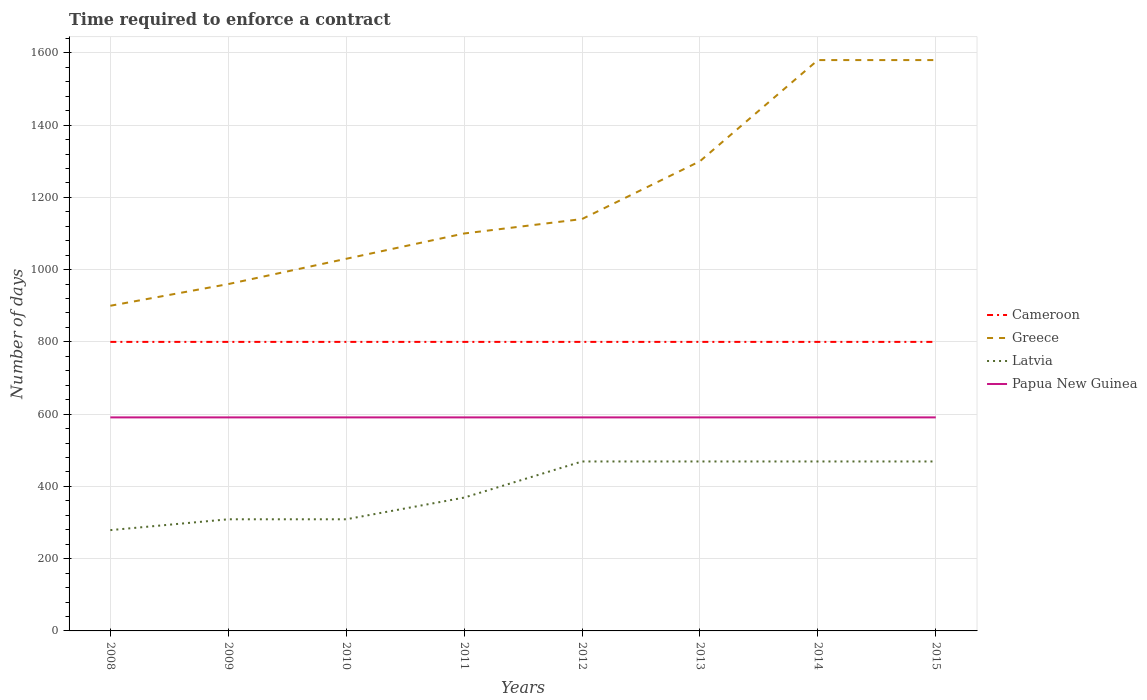Across all years, what is the maximum number of days required to enforce a contract in Greece?
Give a very brief answer. 900. In which year was the number of days required to enforce a contract in Cameroon maximum?
Your answer should be very brief. 2008. What is the difference between the highest and the second highest number of days required to enforce a contract in Cameroon?
Offer a terse response. 0. What is the difference between the highest and the lowest number of days required to enforce a contract in Papua New Guinea?
Provide a short and direct response. 0. How many lines are there?
Your answer should be very brief. 4. How many years are there in the graph?
Keep it short and to the point. 8. What is the difference between two consecutive major ticks on the Y-axis?
Provide a succinct answer. 200. Does the graph contain grids?
Your answer should be very brief. Yes. How are the legend labels stacked?
Offer a terse response. Vertical. What is the title of the graph?
Ensure brevity in your answer.  Time required to enforce a contract. Does "Philippines" appear as one of the legend labels in the graph?
Provide a short and direct response. No. What is the label or title of the X-axis?
Ensure brevity in your answer.  Years. What is the label or title of the Y-axis?
Ensure brevity in your answer.  Number of days. What is the Number of days in Cameroon in 2008?
Provide a short and direct response. 800. What is the Number of days in Greece in 2008?
Keep it short and to the point. 900. What is the Number of days in Latvia in 2008?
Your answer should be very brief. 279. What is the Number of days of Papua New Guinea in 2008?
Your response must be concise. 591. What is the Number of days of Cameroon in 2009?
Your answer should be very brief. 800. What is the Number of days of Greece in 2009?
Keep it short and to the point. 960. What is the Number of days in Latvia in 2009?
Your answer should be very brief. 309. What is the Number of days of Papua New Guinea in 2009?
Offer a terse response. 591. What is the Number of days of Cameroon in 2010?
Your answer should be compact. 800. What is the Number of days in Greece in 2010?
Your answer should be compact. 1030. What is the Number of days of Latvia in 2010?
Ensure brevity in your answer.  309. What is the Number of days of Papua New Guinea in 2010?
Your answer should be compact. 591. What is the Number of days in Cameroon in 2011?
Provide a short and direct response. 800. What is the Number of days of Greece in 2011?
Make the answer very short. 1100. What is the Number of days of Latvia in 2011?
Make the answer very short. 369. What is the Number of days in Papua New Guinea in 2011?
Provide a short and direct response. 591. What is the Number of days of Cameroon in 2012?
Offer a very short reply. 800. What is the Number of days in Greece in 2012?
Provide a succinct answer. 1140. What is the Number of days of Latvia in 2012?
Provide a succinct answer. 469. What is the Number of days of Papua New Guinea in 2012?
Keep it short and to the point. 591. What is the Number of days in Cameroon in 2013?
Ensure brevity in your answer.  800. What is the Number of days in Greece in 2013?
Your answer should be compact. 1300. What is the Number of days in Latvia in 2013?
Ensure brevity in your answer.  469. What is the Number of days in Papua New Guinea in 2013?
Provide a succinct answer. 591. What is the Number of days of Cameroon in 2014?
Offer a very short reply. 800. What is the Number of days in Greece in 2014?
Your response must be concise. 1580. What is the Number of days in Latvia in 2014?
Provide a succinct answer. 469. What is the Number of days of Papua New Guinea in 2014?
Provide a short and direct response. 591. What is the Number of days of Cameroon in 2015?
Give a very brief answer. 800. What is the Number of days in Greece in 2015?
Your answer should be very brief. 1580. What is the Number of days of Latvia in 2015?
Keep it short and to the point. 469. What is the Number of days of Papua New Guinea in 2015?
Your answer should be very brief. 591. Across all years, what is the maximum Number of days of Cameroon?
Provide a short and direct response. 800. Across all years, what is the maximum Number of days of Greece?
Offer a very short reply. 1580. Across all years, what is the maximum Number of days of Latvia?
Ensure brevity in your answer.  469. Across all years, what is the maximum Number of days in Papua New Guinea?
Make the answer very short. 591. Across all years, what is the minimum Number of days of Cameroon?
Provide a short and direct response. 800. Across all years, what is the minimum Number of days in Greece?
Offer a very short reply. 900. Across all years, what is the minimum Number of days in Latvia?
Provide a succinct answer. 279. Across all years, what is the minimum Number of days in Papua New Guinea?
Provide a succinct answer. 591. What is the total Number of days in Cameroon in the graph?
Your answer should be very brief. 6400. What is the total Number of days of Greece in the graph?
Provide a short and direct response. 9590. What is the total Number of days of Latvia in the graph?
Your answer should be very brief. 3142. What is the total Number of days of Papua New Guinea in the graph?
Offer a terse response. 4728. What is the difference between the Number of days of Greece in 2008 and that in 2009?
Your answer should be compact. -60. What is the difference between the Number of days in Latvia in 2008 and that in 2009?
Your answer should be very brief. -30. What is the difference between the Number of days of Papua New Guinea in 2008 and that in 2009?
Provide a short and direct response. 0. What is the difference between the Number of days of Cameroon in 2008 and that in 2010?
Make the answer very short. 0. What is the difference between the Number of days in Greece in 2008 and that in 2010?
Ensure brevity in your answer.  -130. What is the difference between the Number of days in Latvia in 2008 and that in 2010?
Give a very brief answer. -30. What is the difference between the Number of days in Cameroon in 2008 and that in 2011?
Provide a succinct answer. 0. What is the difference between the Number of days in Greece in 2008 and that in 2011?
Give a very brief answer. -200. What is the difference between the Number of days in Latvia in 2008 and that in 2011?
Offer a very short reply. -90. What is the difference between the Number of days in Cameroon in 2008 and that in 2012?
Offer a terse response. 0. What is the difference between the Number of days in Greece in 2008 and that in 2012?
Provide a succinct answer. -240. What is the difference between the Number of days of Latvia in 2008 and that in 2012?
Provide a succinct answer. -190. What is the difference between the Number of days in Papua New Guinea in 2008 and that in 2012?
Ensure brevity in your answer.  0. What is the difference between the Number of days in Cameroon in 2008 and that in 2013?
Your answer should be compact. 0. What is the difference between the Number of days in Greece in 2008 and that in 2013?
Provide a succinct answer. -400. What is the difference between the Number of days of Latvia in 2008 and that in 2013?
Your answer should be very brief. -190. What is the difference between the Number of days in Cameroon in 2008 and that in 2014?
Make the answer very short. 0. What is the difference between the Number of days of Greece in 2008 and that in 2014?
Make the answer very short. -680. What is the difference between the Number of days of Latvia in 2008 and that in 2014?
Offer a very short reply. -190. What is the difference between the Number of days in Greece in 2008 and that in 2015?
Ensure brevity in your answer.  -680. What is the difference between the Number of days of Latvia in 2008 and that in 2015?
Your answer should be very brief. -190. What is the difference between the Number of days in Cameroon in 2009 and that in 2010?
Offer a terse response. 0. What is the difference between the Number of days in Greece in 2009 and that in 2010?
Keep it short and to the point. -70. What is the difference between the Number of days of Papua New Guinea in 2009 and that in 2010?
Provide a short and direct response. 0. What is the difference between the Number of days in Cameroon in 2009 and that in 2011?
Give a very brief answer. 0. What is the difference between the Number of days in Greece in 2009 and that in 2011?
Keep it short and to the point. -140. What is the difference between the Number of days in Latvia in 2009 and that in 2011?
Your answer should be compact. -60. What is the difference between the Number of days in Cameroon in 2009 and that in 2012?
Your answer should be very brief. 0. What is the difference between the Number of days of Greece in 2009 and that in 2012?
Make the answer very short. -180. What is the difference between the Number of days of Latvia in 2009 and that in 2012?
Make the answer very short. -160. What is the difference between the Number of days in Cameroon in 2009 and that in 2013?
Offer a terse response. 0. What is the difference between the Number of days in Greece in 2009 and that in 2013?
Your response must be concise. -340. What is the difference between the Number of days in Latvia in 2009 and that in 2013?
Offer a very short reply. -160. What is the difference between the Number of days in Greece in 2009 and that in 2014?
Offer a very short reply. -620. What is the difference between the Number of days of Latvia in 2009 and that in 2014?
Your response must be concise. -160. What is the difference between the Number of days of Papua New Guinea in 2009 and that in 2014?
Provide a short and direct response. 0. What is the difference between the Number of days in Greece in 2009 and that in 2015?
Offer a terse response. -620. What is the difference between the Number of days in Latvia in 2009 and that in 2015?
Provide a short and direct response. -160. What is the difference between the Number of days in Greece in 2010 and that in 2011?
Offer a terse response. -70. What is the difference between the Number of days in Latvia in 2010 and that in 2011?
Offer a very short reply. -60. What is the difference between the Number of days in Greece in 2010 and that in 2012?
Give a very brief answer. -110. What is the difference between the Number of days of Latvia in 2010 and that in 2012?
Your answer should be very brief. -160. What is the difference between the Number of days of Greece in 2010 and that in 2013?
Ensure brevity in your answer.  -270. What is the difference between the Number of days in Latvia in 2010 and that in 2013?
Your response must be concise. -160. What is the difference between the Number of days of Greece in 2010 and that in 2014?
Make the answer very short. -550. What is the difference between the Number of days in Latvia in 2010 and that in 2014?
Your answer should be very brief. -160. What is the difference between the Number of days of Papua New Guinea in 2010 and that in 2014?
Give a very brief answer. 0. What is the difference between the Number of days in Cameroon in 2010 and that in 2015?
Give a very brief answer. 0. What is the difference between the Number of days of Greece in 2010 and that in 2015?
Your response must be concise. -550. What is the difference between the Number of days in Latvia in 2010 and that in 2015?
Offer a terse response. -160. What is the difference between the Number of days of Cameroon in 2011 and that in 2012?
Your answer should be compact. 0. What is the difference between the Number of days of Latvia in 2011 and that in 2012?
Offer a very short reply. -100. What is the difference between the Number of days of Cameroon in 2011 and that in 2013?
Your answer should be very brief. 0. What is the difference between the Number of days of Greece in 2011 and that in 2013?
Keep it short and to the point. -200. What is the difference between the Number of days of Latvia in 2011 and that in 2013?
Provide a short and direct response. -100. What is the difference between the Number of days in Papua New Guinea in 2011 and that in 2013?
Give a very brief answer. 0. What is the difference between the Number of days of Greece in 2011 and that in 2014?
Offer a terse response. -480. What is the difference between the Number of days of Latvia in 2011 and that in 2014?
Offer a very short reply. -100. What is the difference between the Number of days of Papua New Guinea in 2011 and that in 2014?
Make the answer very short. 0. What is the difference between the Number of days in Cameroon in 2011 and that in 2015?
Provide a short and direct response. 0. What is the difference between the Number of days of Greece in 2011 and that in 2015?
Offer a very short reply. -480. What is the difference between the Number of days in Latvia in 2011 and that in 2015?
Provide a succinct answer. -100. What is the difference between the Number of days of Papua New Guinea in 2011 and that in 2015?
Give a very brief answer. 0. What is the difference between the Number of days in Cameroon in 2012 and that in 2013?
Provide a succinct answer. 0. What is the difference between the Number of days of Greece in 2012 and that in 2013?
Provide a short and direct response. -160. What is the difference between the Number of days of Latvia in 2012 and that in 2013?
Ensure brevity in your answer.  0. What is the difference between the Number of days in Papua New Guinea in 2012 and that in 2013?
Offer a terse response. 0. What is the difference between the Number of days in Cameroon in 2012 and that in 2014?
Give a very brief answer. 0. What is the difference between the Number of days in Greece in 2012 and that in 2014?
Offer a terse response. -440. What is the difference between the Number of days of Latvia in 2012 and that in 2014?
Your answer should be very brief. 0. What is the difference between the Number of days in Greece in 2012 and that in 2015?
Provide a short and direct response. -440. What is the difference between the Number of days of Latvia in 2012 and that in 2015?
Your response must be concise. 0. What is the difference between the Number of days in Papua New Guinea in 2012 and that in 2015?
Offer a very short reply. 0. What is the difference between the Number of days of Cameroon in 2013 and that in 2014?
Ensure brevity in your answer.  0. What is the difference between the Number of days of Greece in 2013 and that in 2014?
Make the answer very short. -280. What is the difference between the Number of days of Cameroon in 2013 and that in 2015?
Ensure brevity in your answer.  0. What is the difference between the Number of days of Greece in 2013 and that in 2015?
Keep it short and to the point. -280. What is the difference between the Number of days of Latvia in 2013 and that in 2015?
Your answer should be very brief. 0. What is the difference between the Number of days of Papua New Guinea in 2013 and that in 2015?
Offer a terse response. 0. What is the difference between the Number of days in Cameroon in 2014 and that in 2015?
Offer a very short reply. 0. What is the difference between the Number of days in Greece in 2014 and that in 2015?
Provide a short and direct response. 0. What is the difference between the Number of days in Latvia in 2014 and that in 2015?
Your response must be concise. 0. What is the difference between the Number of days of Papua New Guinea in 2014 and that in 2015?
Ensure brevity in your answer.  0. What is the difference between the Number of days of Cameroon in 2008 and the Number of days of Greece in 2009?
Offer a terse response. -160. What is the difference between the Number of days of Cameroon in 2008 and the Number of days of Latvia in 2009?
Ensure brevity in your answer.  491. What is the difference between the Number of days of Cameroon in 2008 and the Number of days of Papua New Guinea in 2009?
Make the answer very short. 209. What is the difference between the Number of days of Greece in 2008 and the Number of days of Latvia in 2009?
Provide a short and direct response. 591. What is the difference between the Number of days in Greece in 2008 and the Number of days in Papua New Guinea in 2009?
Ensure brevity in your answer.  309. What is the difference between the Number of days of Latvia in 2008 and the Number of days of Papua New Guinea in 2009?
Offer a very short reply. -312. What is the difference between the Number of days in Cameroon in 2008 and the Number of days in Greece in 2010?
Provide a short and direct response. -230. What is the difference between the Number of days of Cameroon in 2008 and the Number of days of Latvia in 2010?
Make the answer very short. 491. What is the difference between the Number of days of Cameroon in 2008 and the Number of days of Papua New Guinea in 2010?
Your answer should be compact. 209. What is the difference between the Number of days in Greece in 2008 and the Number of days in Latvia in 2010?
Make the answer very short. 591. What is the difference between the Number of days of Greece in 2008 and the Number of days of Papua New Guinea in 2010?
Give a very brief answer. 309. What is the difference between the Number of days in Latvia in 2008 and the Number of days in Papua New Guinea in 2010?
Provide a short and direct response. -312. What is the difference between the Number of days in Cameroon in 2008 and the Number of days in Greece in 2011?
Your response must be concise. -300. What is the difference between the Number of days of Cameroon in 2008 and the Number of days of Latvia in 2011?
Your answer should be compact. 431. What is the difference between the Number of days of Cameroon in 2008 and the Number of days of Papua New Guinea in 2011?
Offer a terse response. 209. What is the difference between the Number of days of Greece in 2008 and the Number of days of Latvia in 2011?
Provide a succinct answer. 531. What is the difference between the Number of days of Greece in 2008 and the Number of days of Papua New Guinea in 2011?
Make the answer very short. 309. What is the difference between the Number of days in Latvia in 2008 and the Number of days in Papua New Guinea in 2011?
Your response must be concise. -312. What is the difference between the Number of days in Cameroon in 2008 and the Number of days in Greece in 2012?
Your answer should be very brief. -340. What is the difference between the Number of days of Cameroon in 2008 and the Number of days of Latvia in 2012?
Make the answer very short. 331. What is the difference between the Number of days in Cameroon in 2008 and the Number of days in Papua New Guinea in 2012?
Offer a very short reply. 209. What is the difference between the Number of days in Greece in 2008 and the Number of days in Latvia in 2012?
Offer a very short reply. 431. What is the difference between the Number of days in Greece in 2008 and the Number of days in Papua New Guinea in 2012?
Make the answer very short. 309. What is the difference between the Number of days of Latvia in 2008 and the Number of days of Papua New Guinea in 2012?
Your answer should be compact. -312. What is the difference between the Number of days of Cameroon in 2008 and the Number of days of Greece in 2013?
Keep it short and to the point. -500. What is the difference between the Number of days of Cameroon in 2008 and the Number of days of Latvia in 2013?
Your answer should be compact. 331. What is the difference between the Number of days in Cameroon in 2008 and the Number of days in Papua New Guinea in 2013?
Your answer should be very brief. 209. What is the difference between the Number of days in Greece in 2008 and the Number of days in Latvia in 2013?
Keep it short and to the point. 431. What is the difference between the Number of days in Greece in 2008 and the Number of days in Papua New Guinea in 2013?
Your answer should be compact. 309. What is the difference between the Number of days in Latvia in 2008 and the Number of days in Papua New Guinea in 2013?
Your response must be concise. -312. What is the difference between the Number of days of Cameroon in 2008 and the Number of days of Greece in 2014?
Make the answer very short. -780. What is the difference between the Number of days of Cameroon in 2008 and the Number of days of Latvia in 2014?
Provide a short and direct response. 331. What is the difference between the Number of days of Cameroon in 2008 and the Number of days of Papua New Guinea in 2014?
Your answer should be compact. 209. What is the difference between the Number of days in Greece in 2008 and the Number of days in Latvia in 2014?
Offer a terse response. 431. What is the difference between the Number of days of Greece in 2008 and the Number of days of Papua New Guinea in 2014?
Make the answer very short. 309. What is the difference between the Number of days of Latvia in 2008 and the Number of days of Papua New Guinea in 2014?
Ensure brevity in your answer.  -312. What is the difference between the Number of days of Cameroon in 2008 and the Number of days of Greece in 2015?
Your answer should be very brief. -780. What is the difference between the Number of days in Cameroon in 2008 and the Number of days in Latvia in 2015?
Offer a terse response. 331. What is the difference between the Number of days of Cameroon in 2008 and the Number of days of Papua New Guinea in 2015?
Offer a terse response. 209. What is the difference between the Number of days of Greece in 2008 and the Number of days of Latvia in 2015?
Provide a short and direct response. 431. What is the difference between the Number of days of Greece in 2008 and the Number of days of Papua New Guinea in 2015?
Give a very brief answer. 309. What is the difference between the Number of days of Latvia in 2008 and the Number of days of Papua New Guinea in 2015?
Give a very brief answer. -312. What is the difference between the Number of days of Cameroon in 2009 and the Number of days of Greece in 2010?
Provide a short and direct response. -230. What is the difference between the Number of days in Cameroon in 2009 and the Number of days in Latvia in 2010?
Offer a terse response. 491. What is the difference between the Number of days in Cameroon in 2009 and the Number of days in Papua New Guinea in 2010?
Your answer should be compact. 209. What is the difference between the Number of days in Greece in 2009 and the Number of days in Latvia in 2010?
Provide a short and direct response. 651. What is the difference between the Number of days in Greece in 2009 and the Number of days in Papua New Guinea in 2010?
Your answer should be very brief. 369. What is the difference between the Number of days of Latvia in 2009 and the Number of days of Papua New Guinea in 2010?
Make the answer very short. -282. What is the difference between the Number of days in Cameroon in 2009 and the Number of days in Greece in 2011?
Your answer should be very brief. -300. What is the difference between the Number of days in Cameroon in 2009 and the Number of days in Latvia in 2011?
Offer a very short reply. 431. What is the difference between the Number of days in Cameroon in 2009 and the Number of days in Papua New Guinea in 2011?
Keep it short and to the point. 209. What is the difference between the Number of days of Greece in 2009 and the Number of days of Latvia in 2011?
Make the answer very short. 591. What is the difference between the Number of days of Greece in 2009 and the Number of days of Papua New Guinea in 2011?
Offer a very short reply. 369. What is the difference between the Number of days in Latvia in 2009 and the Number of days in Papua New Guinea in 2011?
Offer a terse response. -282. What is the difference between the Number of days in Cameroon in 2009 and the Number of days in Greece in 2012?
Give a very brief answer. -340. What is the difference between the Number of days in Cameroon in 2009 and the Number of days in Latvia in 2012?
Your response must be concise. 331. What is the difference between the Number of days of Cameroon in 2009 and the Number of days of Papua New Guinea in 2012?
Provide a short and direct response. 209. What is the difference between the Number of days of Greece in 2009 and the Number of days of Latvia in 2012?
Keep it short and to the point. 491. What is the difference between the Number of days in Greece in 2009 and the Number of days in Papua New Guinea in 2012?
Offer a terse response. 369. What is the difference between the Number of days of Latvia in 2009 and the Number of days of Papua New Guinea in 2012?
Offer a terse response. -282. What is the difference between the Number of days of Cameroon in 2009 and the Number of days of Greece in 2013?
Give a very brief answer. -500. What is the difference between the Number of days of Cameroon in 2009 and the Number of days of Latvia in 2013?
Provide a succinct answer. 331. What is the difference between the Number of days in Cameroon in 2009 and the Number of days in Papua New Guinea in 2013?
Keep it short and to the point. 209. What is the difference between the Number of days of Greece in 2009 and the Number of days of Latvia in 2013?
Keep it short and to the point. 491. What is the difference between the Number of days in Greece in 2009 and the Number of days in Papua New Guinea in 2013?
Provide a short and direct response. 369. What is the difference between the Number of days in Latvia in 2009 and the Number of days in Papua New Guinea in 2013?
Your response must be concise. -282. What is the difference between the Number of days in Cameroon in 2009 and the Number of days in Greece in 2014?
Ensure brevity in your answer.  -780. What is the difference between the Number of days of Cameroon in 2009 and the Number of days of Latvia in 2014?
Offer a terse response. 331. What is the difference between the Number of days in Cameroon in 2009 and the Number of days in Papua New Guinea in 2014?
Offer a terse response. 209. What is the difference between the Number of days in Greece in 2009 and the Number of days in Latvia in 2014?
Give a very brief answer. 491. What is the difference between the Number of days of Greece in 2009 and the Number of days of Papua New Guinea in 2014?
Your answer should be compact. 369. What is the difference between the Number of days of Latvia in 2009 and the Number of days of Papua New Guinea in 2014?
Your answer should be compact. -282. What is the difference between the Number of days in Cameroon in 2009 and the Number of days in Greece in 2015?
Your answer should be very brief. -780. What is the difference between the Number of days in Cameroon in 2009 and the Number of days in Latvia in 2015?
Your response must be concise. 331. What is the difference between the Number of days of Cameroon in 2009 and the Number of days of Papua New Guinea in 2015?
Offer a very short reply. 209. What is the difference between the Number of days in Greece in 2009 and the Number of days in Latvia in 2015?
Your response must be concise. 491. What is the difference between the Number of days of Greece in 2009 and the Number of days of Papua New Guinea in 2015?
Provide a succinct answer. 369. What is the difference between the Number of days of Latvia in 2009 and the Number of days of Papua New Guinea in 2015?
Your answer should be very brief. -282. What is the difference between the Number of days in Cameroon in 2010 and the Number of days in Greece in 2011?
Make the answer very short. -300. What is the difference between the Number of days in Cameroon in 2010 and the Number of days in Latvia in 2011?
Offer a very short reply. 431. What is the difference between the Number of days in Cameroon in 2010 and the Number of days in Papua New Guinea in 2011?
Offer a very short reply. 209. What is the difference between the Number of days of Greece in 2010 and the Number of days of Latvia in 2011?
Ensure brevity in your answer.  661. What is the difference between the Number of days in Greece in 2010 and the Number of days in Papua New Guinea in 2011?
Offer a very short reply. 439. What is the difference between the Number of days of Latvia in 2010 and the Number of days of Papua New Guinea in 2011?
Your response must be concise. -282. What is the difference between the Number of days of Cameroon in 2010 and the Number of days of Greece in 2012?
Your response must be concise. -340. What is the difference between the Number of days in Cameroon in 2010 and the Number of days in Latvia in 2012?
Your answer should be very brief. 331. What is the difference between the Number of days of Cameroon in 2010 and the Number of days of Papua New Guinea in 2012?
Make the answer very short. 209. What is the difference between the Number of days in Greece in 2010 and the Number of days in Latvia in 2012?
Your answer should be compact. 561. What is the difference between the Number of days of Greece in 2010 and the Number of days of Papua New Guinea in 2012?
Your answer should be compact. 439. What is the difference between the Number of days of Latvia in 2010 and the Number of days of Papua New Guinea in 2012?
Give a very brief answer. -282. What is the difference between the Number of days in Cameroon in 2010 and the Number of days in Greece in 2013?
Your answer should be compact. -500. What is the difference between the Number of days in Cameroon in 2010 and the Number of days in Latvia in 2013?
Give a very brief answer. 331. What is the difference between the Number of days of Cameroon in 2010 and the Number of days of Papua New Guinea in 2013?
Offer a terse response. 209. What is the difference between the Number of days in Greece in 2010 and the Number of days in Latvia in 2013?
Your answer should be very brief. 561. What is the difference between the Number of days of Greece in 2010 and the Number of days of Papua New Guinea in 2013?
Offer a very short reply. 439. What is the difference between the Number of days in Latvia in 2010 and the Number of days in Papua New Guinea in 2013?
Your answer should be very brief. -282. What is the difference between the Number of days of Cameroon in 2010 and the Number of days of Greece in 2014?
Your response must be concise. -780. What is the difference between the Number of days in Cameroon in 2010 and the Number of days in Latvia in 2014?
Your answer should be very brief. 331. What is the difference between the Number of days of Cameroon in 2010 and the Number of days of Papua New Guinea in 2014?
Ensure brevity in your answer.  209. What is the difference between the Number of days in Greece in 2010 and the Number of days in Latvia in 2014?
Provide a short and direct response. 561. What is the difference between the Number of days of Greece in 2010 and the Number of days of Papua New Guinea in 2014?
Give a very brief answer. 439. What is the difference between the Number of days of Latvia in 2010 and the Number of days of Papua New Guinea in 2014?
Make the answer very short. -282. What is the difference between the Number of days of Cameroon in 2010 and the Number of days of Greece in 2015?
Provide a succinct answer. -780. What is the difference between the Number of days of Cameroon in 2010 and the Number of days of Latvia in 2015?
Provide a succinct answer. 331. What is the difference between the Number of days of Cameroon in 2010 and the Number of days of Papua New Guinea in 2015?
Ensure brevity in your answer.  209. What is the difference between the Number of days in Greece in 2010 and the Number of days in Latvia in 2015?
Your answer should be very brief. 561. What is the difference between the Number of days of Greece in 2010 and the Number of days of Papua New Guinea in 2015?
Provide a succinct answer. 439. What is the difference between the Number of days in Latvia in 2010 and the Number of days in Papua New Guinea in 2015?
Give a very brief answer. -282. What is the difference between the Number of days in Cameroon in 2011 and the Number of days in Greece in 2012?
Offer a very short reply. -340. What is the difference between the Number of days in Cameroon in 2011 and the Number of days in Latvia in 2012?
Offer a very short reply. 331. What is the difference between the Number of days in Cameroon in 2011 and the Number of days in Papua New Guinea in 2012?
Keep it short and to the point. 209. What is the difference between the Number of days of Greece in 2011 and the Number of days of Latvia in 2012?
Offer a terse response. 631. What is the difference between the Number of days in Greece in 2011 and the Number of days in Papua New Guinea in 2012?
Offer a terse response. 509. What is the difference between the Number of days in Latvia in 2011 and the Number of days in Papua New Guinea in 2012?
Your answer should be compact. -222. What is the difference between the Number of days in Cameroon in 2011 and the Number of days in Greece in 2013?
Give a very brief answer. -500. What is the difference between the Number of days of Cameroon in 2011 and the Number of days of Latvia in 2013?
Ensure brevity in your answer.  331. What is the difference between the Number of days in Cameroon in 2011 and the Number of days in Papua New Guinea in 2013?
Give a very brief answer. 209. What is the difference between the Number of days of Greece in 2011 and the Number of days of Latvia in 2013?
Your response must be concise. 631. What is the difference between the Number of days in Greece in 2011 and the Number of days in Papua New Guinea in 2013?
Your answer should be compact. 509. What is the difference between the Number of days of Latvia in 2011 and the Number of days of Papua New Guinea in 2013?
Provide a succinct answer. -222. What is the difference between the Number of days of Cameroon in 2011 and the Number of days of Greece in 2014?
Offer a terse response. -780. What is the difference between the Number of days in Cameroon in 2011 and the Number of days in Latvia in 2014?
Provide a succinct answer. 331. What is the difference between the Number of days of Cameroon in 2011 and the Number of days of Papua New Guinea in 2014?
Give a very brief answer. 209. What is the difference between the Number of days in Greece in 2011 and the Number of days in Latvia in 2014?
Give a very brief answer. 631. What is the difference between the Number of days in Greece in 2011 and the Number of days in Papua New Guinea in 2014?
Give a very brief answer. 509. What is the difference between the Number of days of Latvia in 2011 and the Number of days of Papua New Guinea in 2014?
Provide a succinct answer. -222. What is the difference between the Number of days in Cameroon in 2011 and the Number of days in Greece in 2015?
Keep it short and to the point. -780. What is the difference between the Number of days of Cameroon in 2011 and the Number of days of Latvia in 2015?
Offer a terse response. 331. What is the difference between the Number of days of Cameroon in 2011 and the Number of days of Papua New Guinea in 2015?
Your response must be concise. 209. What is the difference between the Number of days of Greece in 2011 and the Number of days of Latvia in 2015?
Offer a terse response. 631. What is the difference between the Number of days in Greece in 2011 and the Number of days in Papua New Guinea in 2015?
Provide a succinct answer. 509. What is the difference between the Number of days in Latvia in 2011 and the Number of days in Papua New Guinea in 2015?
Provide a short and direct response. -222. What is the difference between the Number of days of Cameroon in 2012 and the Number of days of Greece in 2013?
Offer a very short reply. -500. What is the difference between the Number of days in Cameroon in 2012 and the Number of days in Latvia in 2013?
Provide a succinct answer. 331. What is the difference between the Number of days of Cameroon in 2012 and the Number of days of Papua New Guinea in 2013?
Give a very brief answer. 209. What is the difference between the Number of days in Greece in 2012 and the Number of days in Latvia in 2013?
Offer a terse response. 671. What is the difference between the Number of days in Greece in 2012 and the Number of days in Papua New Guinea in 2013?
Keep it short and to the point. 549. What is the difference between the Number of days in Latvia in 2012 and the Number of days in Papua New Guinea in 2013?
Give a very brief answer. -122. What is the difference between the Number of days of Cameroon in 2012 and the Number of days of Greece in 2014?
Your answer should be compact. -780. What is the difference between the Number of days in Cameroon in 2012 and the Number of days in Latvia in 2014?
Provide a short and direct response. 331. What is the difference between the Number of days of Cameroon in 2012 and the Number of days of Papua New Guinea in 2014?
Keep it short and to the point. 209. What is the difference between the Number of days of Greece in 2012 and the Number of days of Latvia in 2014?
Your answer should be compact. 671. What is the difference between the Number of days in Greece in 2012 and the Number of days in Papua New Guinea in 2014?
Offer a very short reply. 549. What is the difference between the Number of days in Latvia in 2012 and the Number of days in Papua New Guinea in 2014?
Provide a short and direct response. -122. What is the difference between the Number of days in Cameroon in 2012 and the Number of days in Greece in 2015?
Provide a succinct answer. -780. What is the difference between the Number of days of Cameroon in 2012 and the Number of days of Latvia in 2015?
Your answer should be very brief. 331. What is the difference between the Number of days of Cameroon in 2012 and the Number of days of Papua New Guinea in 2015?
Your answer should be very brief. 209. What is the difference between the Number of days of Greece in 2012 and the Number of days of Latvia in 2015?
Your answer should be very brief. 671. What is the difference between the Number of days in Greece in 2012 and the Number of days in Papua New Guinea in 2015?
Offer a very short reply. 549. What is the difference between the Number of days of Latvia in 2012 and the Number of days of Papua New Guinea in 2015?
Make the answer very short. -122. What is the difference between the Number of days in Cameroon in 2013 and the Number of days in Greece in 2014?
Your answer should be very brief. -780. What is the difference between the Number of days of Cameroon in 2013 and the Number of days of Latvia in 2014?
Your answer should be very brief. 331. What is the difference between the Number of days in Cameroon in 2013 and the Number of days in Papua New Guinea in 2014?
Your answer should be very brief. 209. What is the difference between the Number of days of Greece in 2013 and the Number of days of Latvia in 2014?
Ensure brevity in your answer.  831. What is the difference between the Number of days in Greece in 2013 and the Number of days in Papua New Guinea in 2014?
Your answer should be very brief. 709. What is the difference between the Number of days in Latvia in 2013 and the Number of days in Papua New Guinea in 2014?
Make the answer very short. -122. What is the difference between the Number of days in Cameroon in 2013 and the Number of days in Greece in 2015?
Your answer should be compact. -780. What is the difference between the Number of days in Cameroon in 2013 and the Number of days in Latvia in 2015?
Make the answer very short. 331. What is the difference between the Number of days of Cameroon in 2013 and the Number of days of Papua New Guinea in 2015?
Ensure brevity in your answer.  209. What is the difference between the Number of days of Greece in 2013 and the Number of days of Latvia in 2015?
Your answer should be very brief. 831. What is the difference between the Number of days of Greece in 2013 and the Number of days of Papua New Guinea in 2015?
Ensure brevity in your answer.  709. What is the difference between the Number of days in Latvia in 2013 and the Number of days in Papua New Guinea in 2015?
Give a very brief answer. -122. What is the difference between the Number of days in Cameroon in 2014 and the Number of days in Greece in 2015?
Keep it short and to the point. -780. What is the difference between the Number of days in Cameroon in 2014 and the Number of days in Latvia in 2015?
Give a very brief answer. 331. What is the difference between the Number of days in Cameroon in 2014 and the Number of days in Papua New Guinea in 2015?
Make the answer very short. 209. What is the difference between the Number of days in Greece in 2014 and the Number of days in Latvia in 2015?
Make the answer very short. 1111. What is the difference between the Number of days of Greece in 2014 and the Number of days of Papua New Guinea in 2015?
Offer a terse response. 989. What is the difference between the Number of days in Latvia in 2014 and the Number of days in Papua New Guinea in 2015?
Offer a very short reply. -122. What is the average Number of days in Cameroon per year?
Ensure brevity in your answer.  800. What is the average Number of days of Greece per year?
Ensure brevity in your answer.  1198.75. What is the average Number of days in Latvia per year?
Offer a very short reply. 392.75. What is the average Number of days of Papua New Guinea per year?
Offer a very short reply. 591. In the year 2008, what is the difference between the Number of days of Cameroon and Number of days of Greece?
Give a very brief answer. -100. In the year 2008, what is the difference between the Number of days of Cameroon and Number of days of Latvia?
Provide a succinct answer. 521. In the year 2008, what is the difference between the Number of days of Cameroon and Number of days of Papua New Guinea?
Provide a short and direct response. 209. In the year 2008, what is the difference between the Number of days of Greece and Number of days of Latvia?
Give a very brief answer. 621. In the year 2008, what is the difference between the Number of days in Greece and Number of days in Papua New Guinea?
Offer a terse response. 309. In the year 2008, what is the difference between the Number of days in Latvia and Number of days in Papua New Guinea?
Make the answer very short. -312. In the year 2009, what is the difference between the Number of days of Cameroon and Number of days of Greece?
Ensure brevity in your answer.  -160. In the year 2009, what is the difference between the Number of days of Cameroon and Number of days of Latvia?
Provide a short and direct response. 491. In the year 2009, what is the difference between the Number of days of Cameroon and Number of days of Papua New Guinea?
Offer a terse response. 209. In the year 2009, what is the difference between the Number of days of Greece and Number of days of Latvia?
Your answer should be compact. 651. In the year 2009, what is the difference between the Number of days in Greece and Number of days in Papua New Guinea?
Offer a terse response. 369. In the year 2009, what is the difference between the Number of days of Latvia and Number of days of Papua New Guinea?
Your response must be concise. -282. In the year 2010, what is the difference between the Number of days of Cameroon and Number of days of Greece?
Provide a succinct answer. -230. In the year 2010, what is the difference between the Number of days in Cameroon and Number of days in Latvia?
Keep it short and to the point. 491. In the year 2010, what is the difference between the Number of days in Cameroon and Number of days in Papua New Guinea?
Provide a short and direct response. 209. In the year 2010, what is the difference between the Number of days in Greece and Number of days in Latvia?
Give a very brief answer. 721. In the year 2010, what is the difference between the Number of days of Greece and Number of days of Papua New Guinea?
Provide a succinct answer. 439. In the year 2010, what is the difference between the Number of days in Latvia and Number of days in Papua New Guinea?
Offer a very short reply. -282. In the year 2011, what is the difference between the Number of days of Cameroon and Number of days of Greece?
Provide a succinct answer. -300. In the year 2011, what is the difference between the Number of days of Cameroon and Number of days of Latvia?
Provide a succinct answer. 431. In the year 2011, what is the difference between the Number of days of Cameroon and Number of days of Papua New Guinea?
Your answer should be very brief. 209. In the year 2011, what is the difference between the Number of days of Greece and Number of days of Latvia?
Your answer should be very brief. 731. In the year 2011, what is the difference between the Number of days in Greece and Number of days in Papua New Guinea?
Your answer should be very brief. 509. In the year 2011, what is the difference between the Number of days in Latvia and Number of days in Papua New Guinea?
Provide a short and direct response. -222. In the year 2012, what is the difference between the Number of days in Cameroon and Number of days in Greece?
Keep it short and to the point. -340. In the year 2012, what is the difference between the Number of days in Cameroon and Number of days in Latvia?
Provide a short and direct response. 331. In the year 2012, what is the difference between the Number of days of Cameroon and Number of days of Papua New Guinea?
Your response must be concise. 209. In the year 2012, what is the difference between the Number of days of Greece and Number of days of Latvia?
Ensure brevity in your answer.  671. In the year 2012, what is the difference between the Number of days of Greece and Number of days of Papua New Guinea?
Give a very brief answer. 549. In the year 2012, what is the difference between the Number of days of Latvia and Number of days of Papua New Guinea?
Keep it short and to the point. -122. In the year 2013, what is the difference between the Number of days in Cameroon and Number of days in Greece?
Ensure brevity in your answer.  -500. In the year 2013, what is the difference between the Number of days in Cameroon and Number of days in Latvia?
Make the answer very short. 331. In the year 2013, what is the difference between the Number of days in Cameroon and Number of days in Papua New Guinea?
Ensure brevity in your answer.  209. In the year 2013, what is the difference between the Number of days of Greece and Number of days of Latvia?
Ensure brevity in your answer.  831. In the year 2013, what is the difference between the Number of days in Greece and Number of days in Papua New Guinea?
Your answer should be very brief. 709. In the year 2013, what is the difference between the Number of days in Latvia and Number of days in Papua New Guinea?
Make the answer very short. -122. In the year 2014, what is the difference between the Number of days of Cameroon and Number of days of Greece?
Your response must be concise. -780. In the year 2014, what is the difference between the Number of days of Cameroon and Number of days of Latvia?
Keep it short and to the point. 331. In the year 2014, what is the difference between the Number of days in Cameroon and Number of days in Papua New Guinea?
Provide a succinct answer. 209. In the year 2014, what is the difference between the Number of days of Greece and Number of days of Latvia?
Your answer should be very brief. 1111. In the year 2014, what is the difference between the Number of days in Greece and Number of days in Papua New Guinea?
Your answer should be very brief. 989. In the year 2014, what is the difference between the Number of days of Latvia and Number of days of Papua New Guinea?
Your answer should be very brief. -122. In the year 2015, what is the difference between the Number of days in Cameroon and Number of days in Greece?
Your response must be concise. -780. In the year 2015, what is the difference between the Number of days of Cameroon and Number of days of Latvia?
Provide a succinct answer. 331. In the year 2015, what is the difference between the Number of days of Cameroon and Number of days of Papua New Guinea?
Your answer should be very brief. 209. In the year 2015, what is the difference between the Number of days of Greece and Number of days of Latvia?
Keep it short and to the point. 1111. In the year 2015, what is the difference between the Number of days of Greece and Number of days of Papua New Guinea?
Provide a succinct answer. 989. In the year 2015, what is the difference between the Number of days of Latvia and Number of days of Papua New Guinea?
Your answer should be compact. -122. What is the ratio of the Number of days in Latvia in 2008 to that in 2009?
Provide a succinct answer. 0.9. What is the ratio of the Number of days of Papua New Guinea in 2008 to that in 2009?
Provide a short and direct response. 1. What is the ratio of the Number of days of Cameroon in 2008 to that in 2010?
Offer a very short reply. 1. What is the ratio of the Number of days in Greece in 2008 to that in 2010?
Your answer should be very brief. 0.87. What is the ratio of the Number of days in Latvia in 2008 to that in 2010?
Provide a succinct answer. 0.9. What is the ratio of the Number of days in Cameroon in 2008 to that in 2011?
Ensure brevity in your answer.  1. What is the ratio of the Number of days of Greece in 2008 to that in 2011?
Your answer should be compact. 0.82. What is the ratio of the Number of days of Latvia in 2008 to that in 2011?
Offer a very short reply. 0.76. What is the ratio of the Number of days of Papua New Guinea in 2008 to that in 2011?
Offer a very short reply. 1. What is the ratio of the Number of days of Greece in 2008 to that in 2012?
Keep it short and to the point. 0.79. What is the ratio of the Number of days in Latvia in 2008 to that in 2012?
Offer a very short reply. 0.59. What is the ratio of the Number of days in Cameroon in 2008 to that in 2013?
Your response must be concise. 1. What is the ratio of the Number of days of Greece in 2008 to that in 2013?
Ensure brevity in your answer.  0.69. What is the ratio of the Number of days of Latvia in 2008 to that in 2013?
Provide a short and direct response. 0.59. What is the ratio of the Number of days of Greece in 2008 to that in 2014?
Provide a succinct answer. 0.57. What is the ratio of the Number of days of Latvia in 2008 to that in 2014?
Your answer should be compact. 0.59. What is the ratio of the Number of days of Cameroon in 2008 to that in 2015?
Keep it short and to the point. 1. What is the ratio of the Number of days in Greece in 2008 to that in 2015?
Make the answer very short. 0.57. What is the ratio of the Number of days in Latvia in 2008 to that in 2015?
Ensure brevity in your answer.  0.59. What is the ratio of the Number of days in Cameroon in 2009 to that in 2010?
Your response must be concise. 1. What is the ratio of the Number of days in Greece in 2009 to that in 2010?
Provide a succinct answer. 0.93. What is the ratio of the Number of days of Latvia in 2009 to that in 2010?
Ensure brevity in your answer.  1. What is the ratio of the Number of days of Cameroon in 2009 to that in 2011?
Provide a succinct answer. 1. What is the ratio of the Number of days of Greece in 2009 to that in 2011?
Offer a very short reply. 0.87. What is the ratio of the Number of days in Latvia in 2009 to that in 2011?
Make the answer very short. 0.84. What is the ratio of the Number of days in Cameroon in 2009 to that in 2012?
Your answer should be compact. 1. What is the ratio of the Number of days of Greece in 2009 to that in 2012?
Offer a very short reply. 0.84. What is the ratio of the Number of days of Latvia in 2009 to that in 2012?
Your answer should be compact. 0.66. What is the ratio of the Number of days in Papua New Guinea in 2009 to that in 2012?
Provide a short and direct response. 1. What is the ratio of the Number of days in Cameroon in 2009 to that in 2013?
Offer a terse response. 1. What is the ratio of the Number of days of Greece in 2009 to that in 2013?
Your answer should be very brief. 0.74. What is the ratio of the Number of days in Latvia in 2009 to that in 2013?
Keep it short and to the point. 0.66. What is the ratio of the Number of days of Greece in 2009 to that in 2014?
Your answer should be compact. 0.61. What is the ratio of the Number of days of Latvia in 2009 to that in 2014?
Offer a very short reply. 0.66. What is the ratio of the Number of days in Papua New Guinea in 2009 to that in 2014?
Ensure brevity in your answer.  1. What is the ratio of the Number of days of Cameroon in 2009 to that in 2015?
Offer a very short reply. 1. What is the ratio of the Number of days of Greece in 2009 to that in 2015?
Provide a succinct answer. 0.61. What is the ratio of the Number of days of Latvia in 2009 to that in 2015?
Offer a terse response. 0.66. What is the ratio of the Number of days in Papua New Guinea in 2009 to that in 2015?
Make the answer very short. 1. What is the ratio of the Number of days in Greece in 2010 to that in 2011?
Keep it short and to the point. 0.94. What is the ratio of the Number of days in Latvia in 2010 to that in 2011?
Make the answer very short. 0.84. What is the ratio of the Number of days in Cameroon in 2010 to that in 2012?
Your response must be concise. 1. What is the ratio of the Number of days in Greece in 2010 to that in 2012?
Your answer should be compact. 0.9. What is the ratio of the Number of days of Latvia in 2010 to that in 2012?
Your answer should be compact. 0.66. What is the ratio of the Number of days in Papua New Guinea in 2010 to that in 2012?
Your answer should be very brief. 1. What is the ratio of the Number of days of Cameroon in 2010 to that in 2013?
Offer a very short reply. 1. What is the ratio of the Number of days in Greece in 2010 to that in 2013?
Give a very brief answer. 0.79. What is the ratio of the Number of days of Latvia in 2010 to that in 2013?
Make the answer very short. 0.66. What is the ratio of the Number of days in Papua New Guinea in 2010 to that in 2013?
Keep it short and to the point. 1. What is the ratio of the Number of days in Cameroon in 2010 to that in 2014?
Your answer should be compact. 1. What is the ratio of the Number of days of Greece in 2010 to that in 2014?
Keep it short and to the point. 0.65. What is the ratio of the Number of days in Latvia in 2010 to that in 2014?
Make the answer very short. 0.66. What is the ratio of the Number of days in Greece in 2010 to that in 2015?
Ensure brevity in your answer.  0.65. What is the ratio of the Number of days in Latvia in 2010 to that in 2015?
Provide a succinct answer. 0.66. What is the ratio of the Number of days in Papua New Guinea in 2010 to that in 2015?
Offer a very short reply. 1. What is the ratio of the Number of days in Greece in 2011 to that in 2012?
Your answer should be compact. 0.96. What is the ratio of the Number of days of Latvia in 2011 to that in 2012?
Keep it short and to the point. 0.79. What is the ratio of the Number of days in Greece in 2011 to that in 2013?
Offer a terse response. 0.85. What is the ratio of the Number of days of Latvia in 2011 to that in 2013?
Offer a very short reply. 0.79. What is the ratio of the Number of days in Cameroon in 2011 to that in 2014?
Keep it short and to the point. 1. What is the ratio of the Number of days in Greece in 2011 to that in 2014?
Give a very brief answer. 0.7. What is the ratio of the Number of days of Latvia in 2011 to that in 2014?
Give a very brief answer. 0.79. What is the ratio of the Number of days in Greece in 2011 to that in 2015?
Provide a short and direct response. 0.7. What is the ratio of the Number of days in Latvia in 2011 to that in 2015?
Your answer should be compact. 0.79. What is the ratio of the Number of days of Papua New Guinea in 2011 to that in 2015?
Give a very brief answer. 1. What is the ratio of the Number of days of Greece in 2012 to that in 2013?
Offer a terse response. 0.88. What is the ratio of the Number of days in Latvia in 2012 to that in 2013?
Your answer should be compact. 1. What is the ratio of the Number of days in Papua New Guinea in 2012 to that in 2013?
Give a very brief answer. 1. What is the ratio of the Number of days of Greece in 2012 to that in 2014?
Keep it short and to the point. 0.72. What is the ratio of the Number of days of Latvia in 2012 to that in 2014?
Provide a short and direct response. 1. What is the ratio of the Number of days of Cameroon in 2012 to that in 2015?
Your response must be concise. 1. What is the ratio of the Number of days in Greece in 2012 to that in 2015?
Offer a terse response. 0.72. What is the ratio of the Number of days of Papua New Guinea in 2012 to that in 2015?
Ensure brevity in your answer.  1. What is the ratio of the Number of days of Cameroon in 2013 to that in 2014?
Your response must be concise. 1. What is the ratio of the Number of days of Greece in 2013 to that in 2014?
Ensure brevity in your answer.  0.82. What is the ratio of the Number of days of Latvia in 2013 to that in 2014?
Give a very brief answer. 1. What is the ratio of the Number of days of Papua New Guinea in 2013 to that in 2014?
Provide a succinct answer. 1. What is the ratio of the Number of days in Cameroon in 2013 to that in 2015?
Your answer should be very brief. 1. What is the ratio of the Number of days of Greece in 2013 to that in 2015?
Provide a succinct answer. 0.82. What is the ratio of the Number of days in Papua New Guinea in 2013 to that in 2015?
Ensure brevity in your answer.  1. What is the ratio of the Number of days in Cameroon in 2014 to that in 2015?
Provide a succinct answer. 1. What is the ratio of the Number of days of Latvia in 2014 to that in 2015?
Make the answer very short. 1. What is the ratio of the Number of days of Papua New Guinea in 2014 to that in 2015?
Your answer should be very brief. 1. What is the difference between the highest and the second highest Number of days in Greece?
Keep it short and to the point. 0. What is the difference between the highest and the second highest Number of days in Latvia?
Make the answer very short. 0. What is the difference between the highest and the lowest Number of days of Cameroon?
Your answer should be compact. 0. What is the difference between the highest and the lowest Number of days of Greece?
Your response must be concise. 680. What is the difference between the highest and the lowest Number of days of Latvia?
Ensure brevity in your answer.  190. 